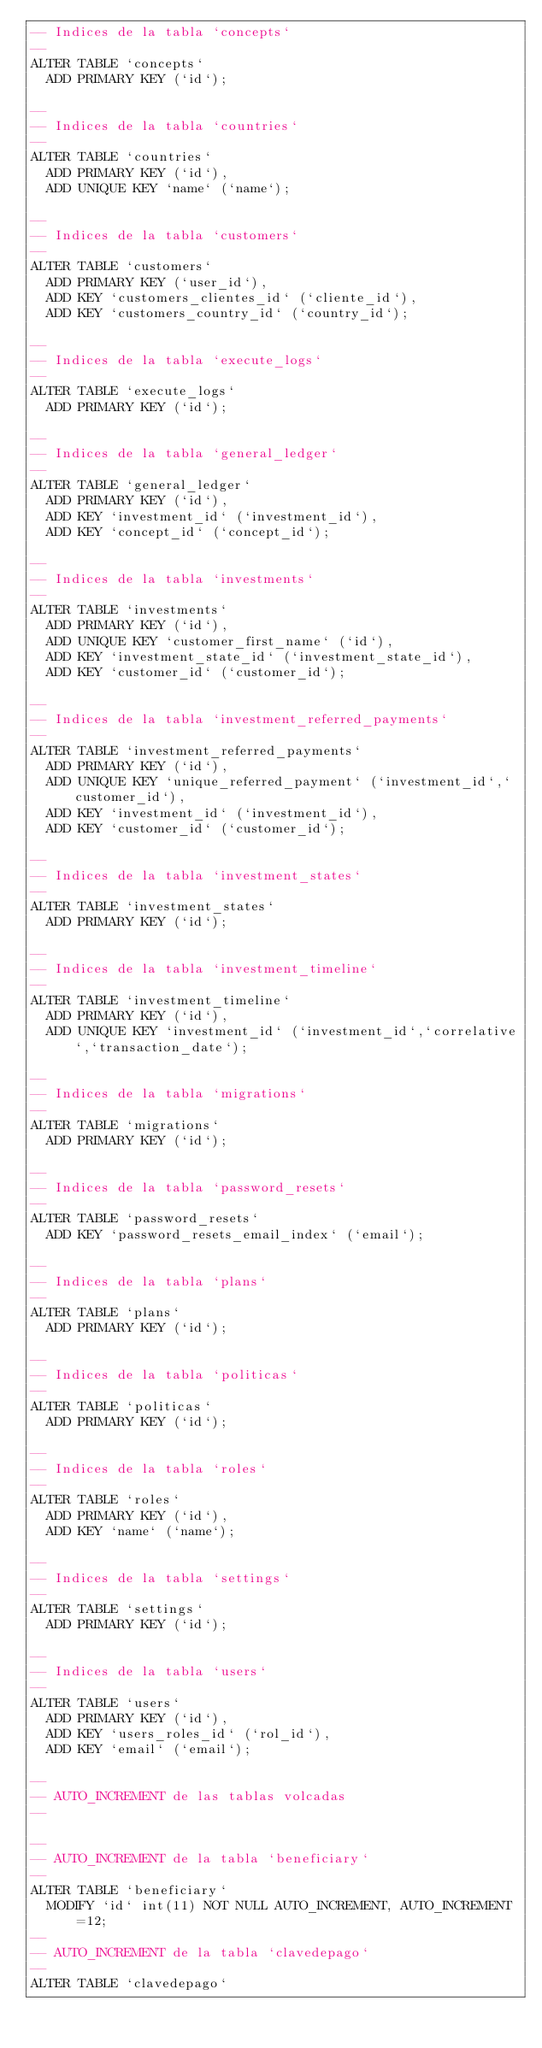<code> <loc_0><loc_0><loc_500><loc_500><_SQL_>-- Indices de la tabla `concepts`
--
ALTER TABLE `concepts`
  ADD PRIMARY KEY (`id`);

--
-- Indices de la tabla `countries`
--
ALTER TABLE `countries`
  ADD PRIMARY KEY (`id`),
  ADD UNIQUE KEY `name` (`name`);

--
-- Indices de la tabla `customers`
--
ALTER TABLE `customers`
  ADD PRIMARY KEY (`user_id`),
  ADD KEY `customers_clientes_id` (`cliente_id`),
  ADD KEY `customers_country_id` (`country_id`);

--
-- Indices de la tabla `execute_logs`
--
ALTER TABLE `execute_logs`
  ADD PRIMARY KEY (`id`);

--
-- Indices de la tabla `general_ledger`
--
ALTER TABLE `general_ledger`
  ADD PRIMARY KEY (`id`),
  ADD KEY `investment_id` (`investment_id`),
  ADD KEY `concept_id` (`concept_id`);

--
-- Indices de la tabla `investments`
--
ALTER TABLE `investments`
  ADD PRIMARY KEY (`id`),
  ADD UNIQUE KEY `customer_first_name` (`id`),
  ADD KEY `investment_state_id` (`investment_state_id`),
  ADD KEY `customer_id` (`customer_id`);

--
-- Indices de la tabla `investment_referred_payments`
--
ALTER TABLE `investment_referred_payments`
  ADD PRIMARY KEY (`id`),
  ADD UNIQUE KEY `unique_referred_payment` (`investment_id`,`customer_id`),
  ADD KEY `investment_id` (`investment_id`),
  ADD KEY `customer_id` (`customer_id`);

--
-- Indices de la tabla `investment_states`
--
ALTER TABLE `investment_states`
  ADD PRIMARY KEY (`id`);

--
-- Indices de la tabla `investment_timeline`
--
ALTER TABLE `investment_timeline`
  ADD PRIMARY KEY (`id`),
  ADD UNIQUE KEY `investment_id` (`investment_id`,`correlative`,`transaction_date`);

--
-- Indices de la tabla `migrations`
--
ALTER TABLE `migrations`
  ADD PRIMARY KEY (`id`);

--
-- Indices de la tabla `password_resets`
--
ALTER TABLE `password_resets`
  ADD KEY `password_resets_email_index` (`email`);

--
-- Indices de la tabla `plans`
--
ALTER TABLE `plans`
  ADD PRIMARY KEY (`id`);

--
-- Indices de la tabla `politicas`
--
ALTER TABLE `politicas`
  ADD PRIMARY KEY (`id`);

--
-- Indices de la tabla `roles`
--
ALTER TABLE `roles`
  ADD PRIMARY KEY (`id`),
  ADD KEY `name` (`name`);

--
-- Indices de la tabla `settings`
--
ALTER TABLE `settings`
  ADD PRIMARY KEY (`id`);

--
-- Indices de la tabla `users`
--
ALTER TABLE `users`
  ADD PRIMARY KEY (`id`),
  ADD KEY `users_roles_id` (`rol_id`),
  ADD KEY `email` (`email`);

--
-- AUTO_INCREMENT de las tablas volcadas
--

--
-- AUTO_INCREMENT de la tabla `beneficiary`
--
ALTER TABLE `beneficiary`
  MODIFY `id` int(11) NOT NULL AUTO_INCREMENT, AUTO_INCREMENT=12;
--
-- AUTO_INCREMENT de la tabla `clavedepago`
--
ALTER TABLE `clavedepago`</code> 